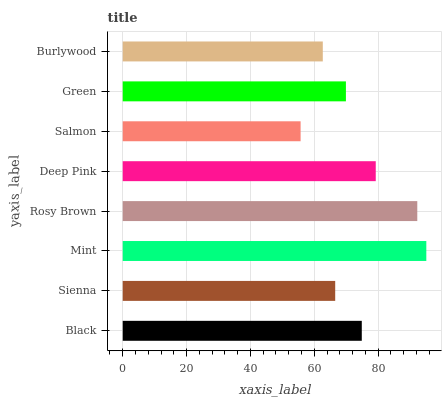Is Salmon the minimum?
Answer yes or no. Yes. Is Mint the maximum?
Answer yes or no. Yes. Is Sienna the minimum?
Answer yes or no. No. Is Sienna the maximum?
Answer yes or no. No. Is Black greater than Sienna?
Answer yes or no. Yes. Is Sienna less than Black?
Answer yes or no. Yes. Is Sienna greater than Black?
Answer yes or no. No. Is Black less than Sienna?
Answer yes or no. No. Is Black the high median?
Answer yes or no. Yes. Is Green the low median?
Answer yes or no. Yes. Is Deep Pink the high median?
Answer yes or no. No. Is Salmon the low median?
Answer yes or no. No. 